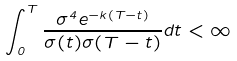Convert formula to latex. <formula><loc_0><loc_0><loc_500><loc_500>\int _ { 0 } ^ { T } \frac { \sigma ^ { 4 } e ^ { - k ( T - t ) } } { \sigma ( t ) \sigma ( T - t ) } d t < \infty</formula> 